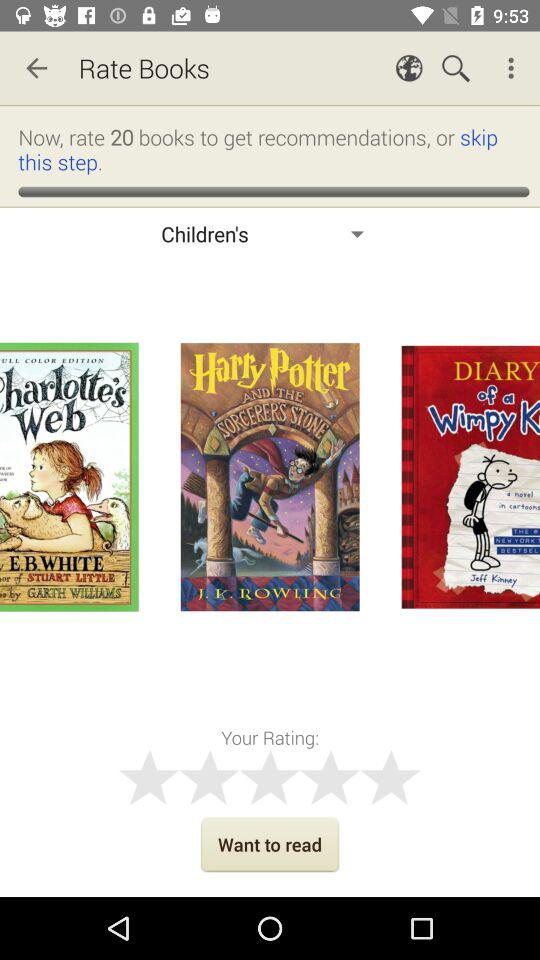Who is the author of the book "Charlotte's Web"? The author of the book "Charlotte's Web" is E.B. White. 